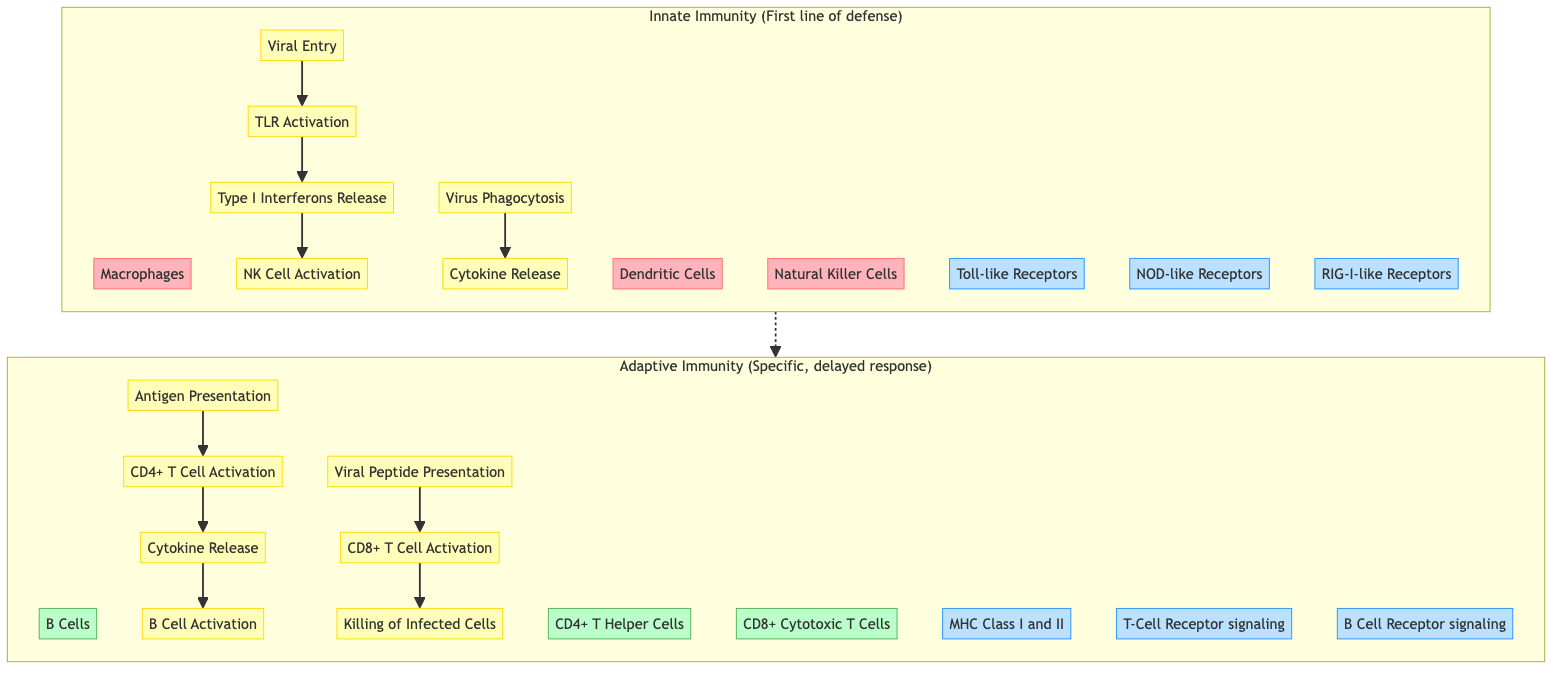What are the key cell types in Innate Immunity? The key cell types in Innate Immunity are listed in the subgraph labelled "Innate Immunity" which includes Macrophages, Dendritic Cells, and Natural Killer Cells.
Answer: Macrophages, Dendritic Cells, Natural Killer Cells How many signaling pathways are involved in the Innate Immunity section? The Innate Immunity section includes three signaling pathways: Toll-like Receptors, NOD-like Receptors, and RIG-I-like Receptors.
Answer: 3 Which process initiates TLR Activation in the diagram? The process that initiates TLR Activation is Viral Entry, as indicated by the directed edge leading to TLR Activation.
Answer: Viral Entry What is the relationship between CD4+ T Cell Activation and B Cell Activation? CD4+ T Cell Activation leads to Cytokine Release, which subsequently leads to B Cell Activation, indicating a flow of influence from CD4+ T Cells to B Cells.
Answer: CD4+ T Cell Activation leads to B Cell Activation What type of immunity is indicated as the first line of defense in the diagram? The first line of defense in the diagram is indicated as Innate Immunity, as specified in the subgraph header.
Answer: Innate Immunity How does NK Cell Activation occur according to the diagram? NK Cell Activation occurs after the release of Type I Interferons, showing a direct relationship between these two events in the innate immune response.
Answer: After Type I Interferons Release What two cell types are involved in the killing of infected cells? The two cell types involved in the killing of infected cells are CD8+ Cytotoxic T Cells and Natural Killer Cells, both of which are shown as key players in the immune response.
Answer: CD8+ Cytotoxic T Cells, Natural Killer Cells Which event is directly linked to Viral Peptide Presentation? Viral Peptide Presentation is directly linked to CD8+ T Cell Activation, indicating that it plays a critical role in activating cytotoxic T cells against viral infections.
Answer: CD8+ T Cell Activation What does the arrow from IFN in the Innate Immunity section lead to? The arrow from IFN in the Innate Immunity section leads to NK Cell Activation, indicating it plays a role in activating natural killer cells.
Answer: NK Cell Activation 